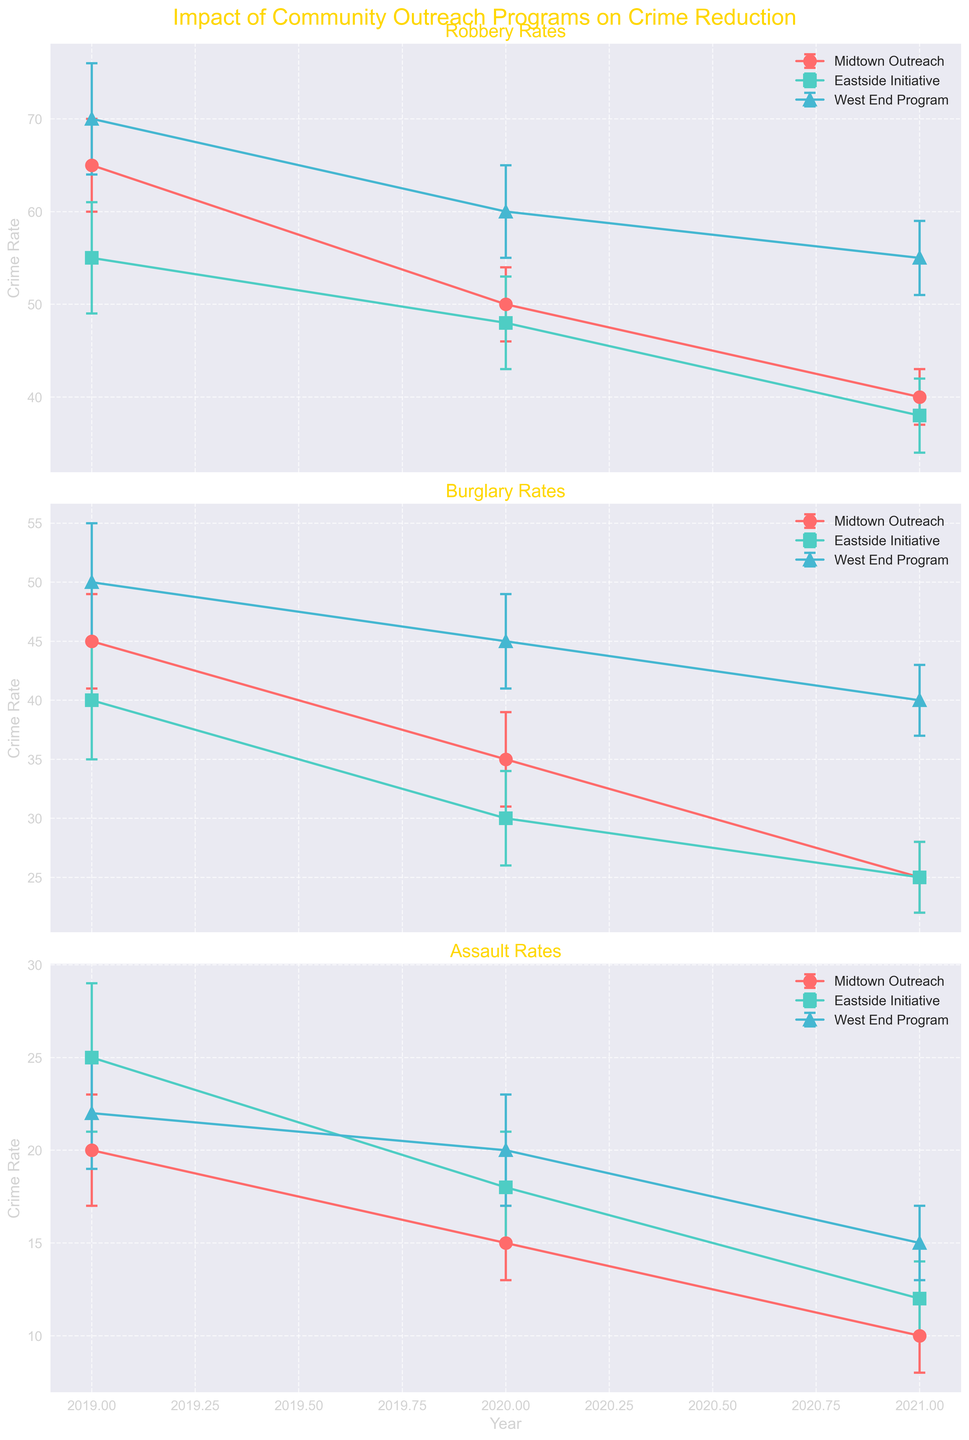What are the crime types analyzed in the figure? The figure has three subplots with titles indicating the crime types analyzed. The titles are "Robbery Rates," "Burglary Rates," and "Assault Rates."
Answer: Robbery, Burglary, Assault Which community outreach program showed the largest reduction in robbery rate from 2019 to 2021? In the first subplot "Robbery Rates," look at the trend lines for each program. For 'Midtown Outreach', the rate decreased from 65 to 40, a reduction of 25. For 'Eastside Initiative', the rate decreased from 55 to 38, a reduction of 17. For 'West End Program', the rate decreased from 70 to 55, a reduction of 15.
Answer: Midtown Outreach In which year did the Eastside Initiative have the lowest burglary rate, and what was it? In the second subplot "Burglary Rates," examine the error bars for 'Eastside Initiative' across years 2019, 2020, and 2021. The lowest burglary rate was in 2020 at a rate of 30.
Answer: 2020, 30 What is the common axis label across all subplots and what does it represent? Each subplot has a common y-axis label which is found on the left side of each subplot indicating "Crime Rate." This represents the mean crime rates with error bars.
Answer: Crime Rate Which program had a smaller standard deviation in burglary rates in 2019, Midtown Outreach or Eastside Initiative? Check the second subplot "Burglary Rates," looking at the error bars' lengths. Midtown Outreach has a standard deviation of 4, while Eastside Initiative has a standard deviation of 5.
Answer: Midtown Outreach Compare the assault rate trends in the Midtown Outreach and Eastside Initiative from 2019 to 2021. Which program shows a more substantial reduction? Inspect the third subplot "Assault Rates" and see the trends for 'Midtown Outreach' and 'Eastside Initiative.' Midtown Outreach decreased from 20 to 10 (10 units reduction), while Eastside Initiative decreased from 25 to 12 (13 units reduction).
Answer: Eastside Initiative What is the trend of burglary rates for the West End Program from 2019 to 2021, and is it consistent across years? In the second subplot "Burglary Rates," observe the trend line for 'West End Program.' The burglary rate started at 50 in 2019, decreased to 45 in 2020, and further decreased to 40 in 2021, showing a consistent yearly decline.
Answer: Consistent decrease For the year 2021, which crime type had the smallest mean crime rate in any of the programs, and what is the value? Look across all subplots for the year 2021 and compare the values. In the third subplot "Assault Rates," 'Midtown Outreach' has the smallest mean crime rate, which is 10.
Answer: Assault in Midtown Outreach, 10 Which subplot indicates the use of at least three different colors, and what purpose do these colors serve? Each subplot uses different colors to represent different community outreach programs. This aids in distinguishing between 'Midtown Outreach,' 'Eastside Initiative,' and 'West End Program.'
Answer: All subplots By how much did the mean crime rate for robbery in the Midtown Outreach program decrease between 2019 and 2020? In the first subplot "Robbery Rates," note the values for the years 2019 and 2020 for 'Midtown Outreach.' The rate decreased from 65 to 50, which is a reduction of 15 units.
Answer: 15 units 